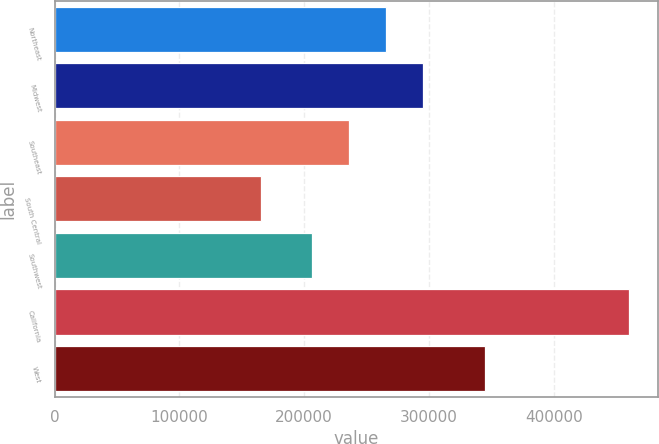<chart> <loc_0><loc_0><loc_500><loc_500><bar_chart><fcel>Northeast<fcel>Midwest<fcel>Southeast<fcel>South Central<fcel>Southwest<fcel>California<fcel>West<nl><fcel>265580<fcel>295120<fcel>236040<fcel>165200<fcel>206500<fcel>460600<fcel>345300<nl></chart> 